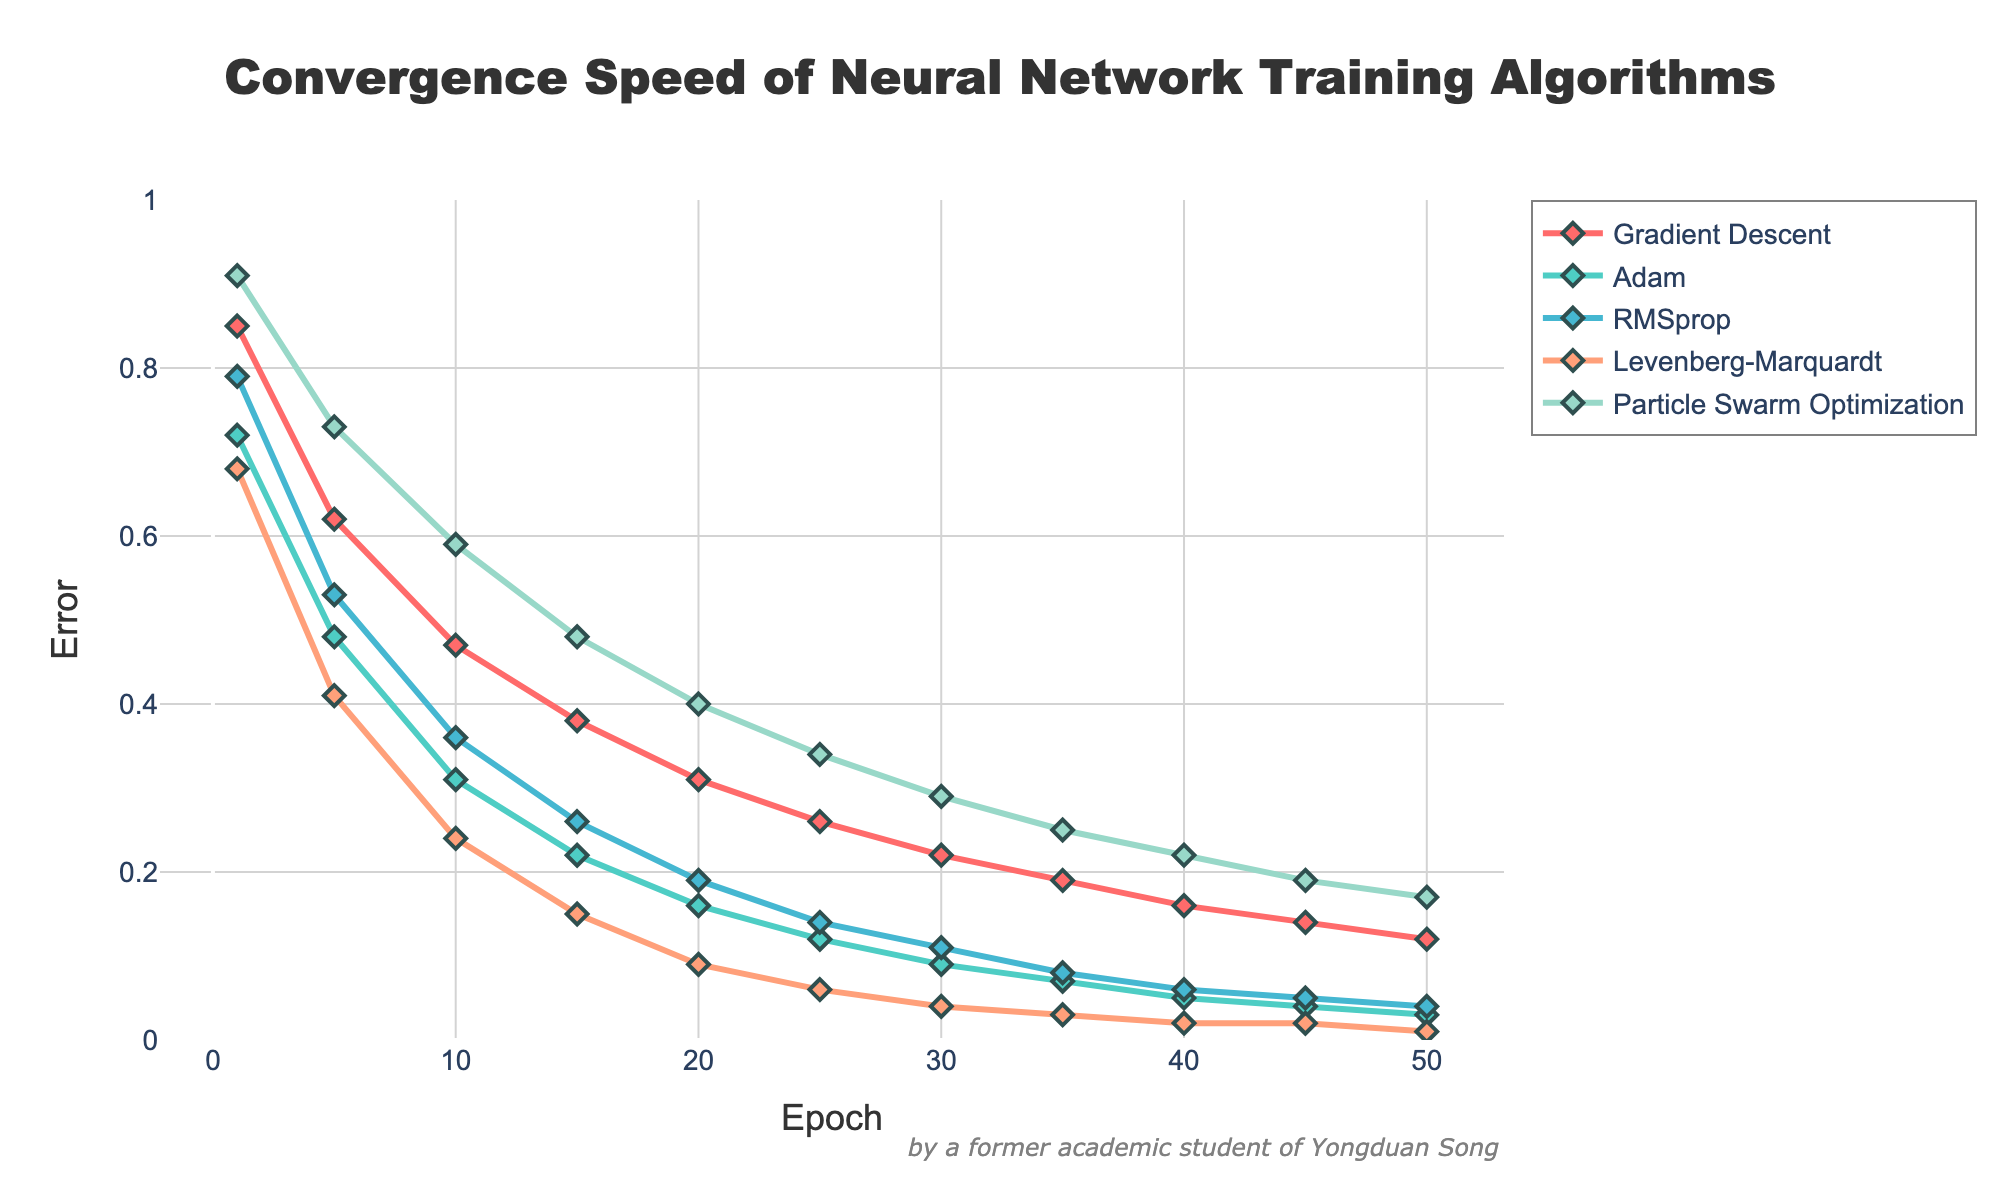What's the final error value for Adam after 50 epochs? To find the final error value for Adam after 50 epochs, look at the point where the Adam line reaches the 50th epoch on the x-axis.
Answer: 0.03 At which epoch does the Levenberg-Marquardt algorithm reach an error less than 0.1? To find the epoch when the Levenberg-Marquardt algorithm reaches an error less than 0.1, look at the vertical points where Levenberg-Marquardt's line crosses the 0.1 error mark on the y-axis.
Answer: 20 What is the difference in error reduction between Gradient Descent and RMSprop at the 25th epoch? To find the difference in error reduction between Gradient Descent and RMSprop at the 25th epoch, subtract the RMSprop value from the Gradient Descent value at epoch 25. Gradient Descent is at 0.26, and RMSprop is at 0.14, yielding 0.26 - 0.14.
Answer: 0.12 Which algorithm shows the fastest initial convergence within the first 5 epochs? To determine the fastest initial convergence, compare the error reduction of all algorithms from epoch 1 to epoch 5. Look for the algorithm with the steepest initial decrease.
Answer: Levenberg-Marquardt What color represents the Particle Swarm Optimization line? To identify the line color for Particle Swarm Optimization, refer to the plot legend to match the algorithm with its corresponding line color.
Answer: Green Which algorithm achieves the lowest error after 30 epochs? To find the algorithm with the lowest error after 30 epochs, identify the lowest data point on the y-axis at epoch 30.
Answer: Levenberg-Marquardt By how much does the error of the Gradient Descent algorithm change from epoch 10 to epoch 45? The error at epoch 10 for Gradient Descent is 0.47, and at epoch 45, it's 0.14. Calculate the change by subtracting the latter from the former: 0.47 - 0.14.
Answer: 0.33 Which two algorithms show similar performance between epoch 25 and epoch 50? To find algorithms with similar performance, compare the slope and convergence behavior of their lines between epoch 25 and epoch 50. Look for lines that have roughly the same trajectory.
Answer: Adam and RMSprop At what epoch does Gradient Descent achieve an error equal to or better than the initial error of Particle Swarm Optimization at epoch 1? Initial error of Particle Swarm Optimization at epoch 1 is 0.91. Locate the epoch on Gradient Descent's line where the error is 0.91 or less.
Answer: 1 What is the average error of the Levenberg-Marquardt algorithm over the first 10 epochs? To find the average error, sum the error values of the Levenberg-Marquardt algorithm from epoch 1 to epoch 10, then divide by the number of epochs (10). The errors are 0.68, 0.41, 0.24. So (0.68 + 0.41 + 0.24) / 10.
Answer: 0.35 